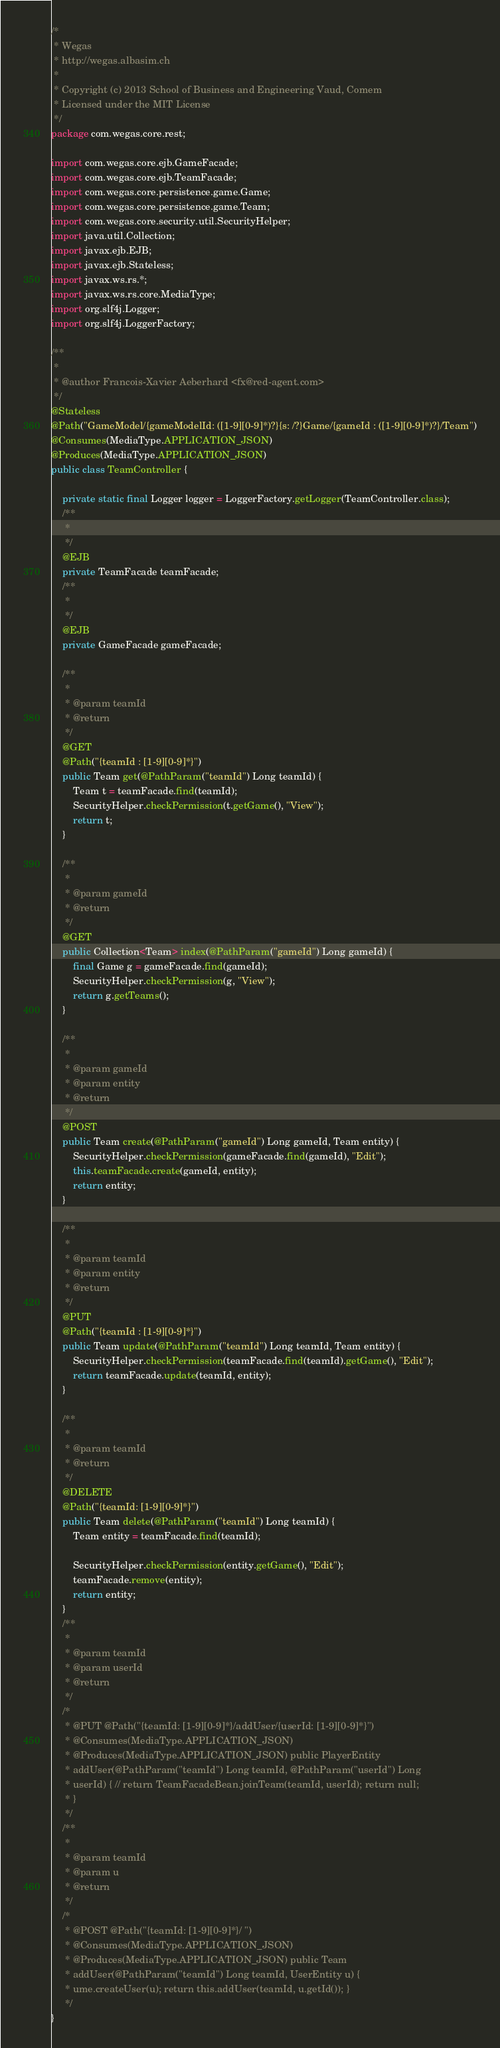Convert code to text. <code><loc_0><loc_0><loc_500><loc_500><_Java_>/*
 * Wegas
 * http://wegas.albasim.ch
 *
 * Copyright (c) 2013 School of Business and Engineering Vaud, Comem
 * Licensed under the MIT License
 */
package com.wegas.core.rest;

import com.wegas.core.ejb.GameFacade;
import com.wegas.core.ejb.TeamFacade;
import com.wegas.core.persistence.game.Game;
import com.wegas.core.persistence.game.Team;
import com.wegas.core.security.util.SecurityHelper;
import java.util.Collection;
import javax.ejb.EJB;
import javax.ejb.Stateless;
import javax.ws.rs.*;
import javax.ws.rs.core.MediaType;
import org.slf4j.Logger;
import org.slf4j.LoggerFactory;

/**
 *
 * @author Francois-Xavier Aeberhard <fx@red-agent.com>
 */
@Stateless
@Path("GameModel/{gameModelId: ([1-9][0-9]*)?}{s: /?}Game/{gameId : ([1-9][0-9]*)?}/Team")
@Consumes(MediaType.APPLICATION_JSON)
@Produces(MediaType.APPLICATION_JSON)
public class TeamController {

    private static final Logger logger = LoggerFactory.getLogger(TeamController.class);
    /**
     *
     */
    @EJB
    private TeamFacade teamFacade;
    /**
     *
     */
    @EJB
    private GameFacade gameFacade;

    /**
     *
     * @param teamId
     * @return
     */
    @GET
    @Path("{teamId : [1-9][0-9]*}")
    public Team get(@PathParam("teamId") Long teamId) {
        Team t = teamFacade.find(teamId);
        SecurityHelper.checkPermission(t.getGame(), "View");
        return t;
    }

    /**
     *
     * @param gameId
     * @return
     */
    @GET
    public Collection<Team> index(@PathParam("gameId") Long gameId) {
        final Game g = gameFacade.find(gameId);
        SecurityHelper.checkPermission(g, "View");
        return g.getTeams();
    }

    /**
     *
     * @param gameId
     * @param entity
     * @return
     */
    @POST
    public Team create(@PathParam("gameId") Long gameId, Team entity) {
        SecurityHelper.checkPermission(gameFacade.find(gameId), "Edit");
        this.teamFacade.create(gameId, entity);
        return entity;
    }

    /**
     *
     * @param teamId
     * @param entity
     * @return
     */
    @PUT
    @Path("{teamId : [1-9][0-9]*}")
    public Team update(@PathParam("teamId") Long teamId, Team entity) {
        SecurityHelper.checkPermission(teamFacade.find(teamId).getGame(), "Edit");
        return teamFacade.update(teamId, entity);
    }

    /**
     *
     * @param teamId
     * @return
     */
    @DELETE
    @Path("{teamId: [1-9][0-9]*}")
    public Team delete(@PathParam("teamId") Long teamId) {
        Team entity = teamFacade.find(teamId);

        SecurityHelper.checkPermission(entity.getGame(), "Edit");
        teamFacade.remove(entity);
        return entity;
    }
    /**
     *
     * @param teamId
     * @param userId
     * @return
     */
    /*
     * @PUT @Path("{teamId: [1-9][0-9]*}/addUser/{userId: [1-9][0-9]*}")
     * @Consumes(MediaType.APPLICATION_JSON)
     * @Produces(MediaType.APPLICATION_JSON) public PlayerEntity
     * addUser(@PathParam("teamId") Long teamId, @PathParam("userId") Long
     * userId) { // return TeamFacadeBean.joinTeam(teamId, userId); return null;
     * }
     */
    /**
     *
     * @param teamId
     * @param u
     * @return
     */
    /*
     * @POST @Path("{teamId: [1-9][0-9]*}/ ")
     * @Consumes(MediaType.APPLICATION_JSON)
     * @Produces(MediaType.APPLICATION_JSON) public Team
     * addUser(@PathParam("teamId") Long teamId, UserEntity u) {
     * ume.createUser(u); return this.addUser(teamId, u.getId()); }
     */
}
</code> 